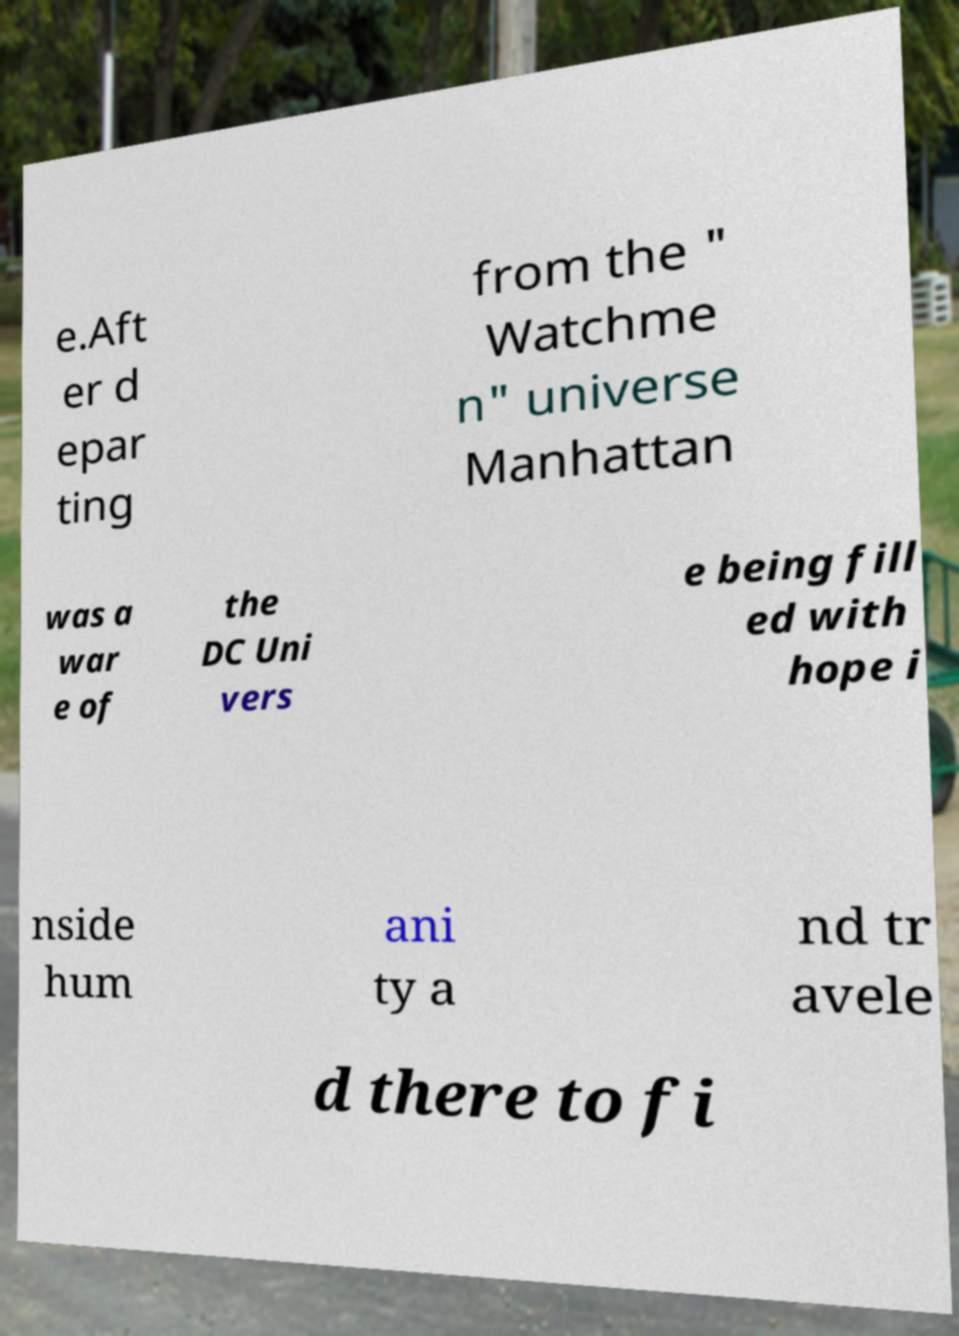Please identify and transcribe the text found in this image. e.Aft er d epar ting from the " Watchme n" universe Manhattan was a war e of the DC Uni vers e being fill ed with hope i nside hum ani ty a nd tr avele d there to fi 